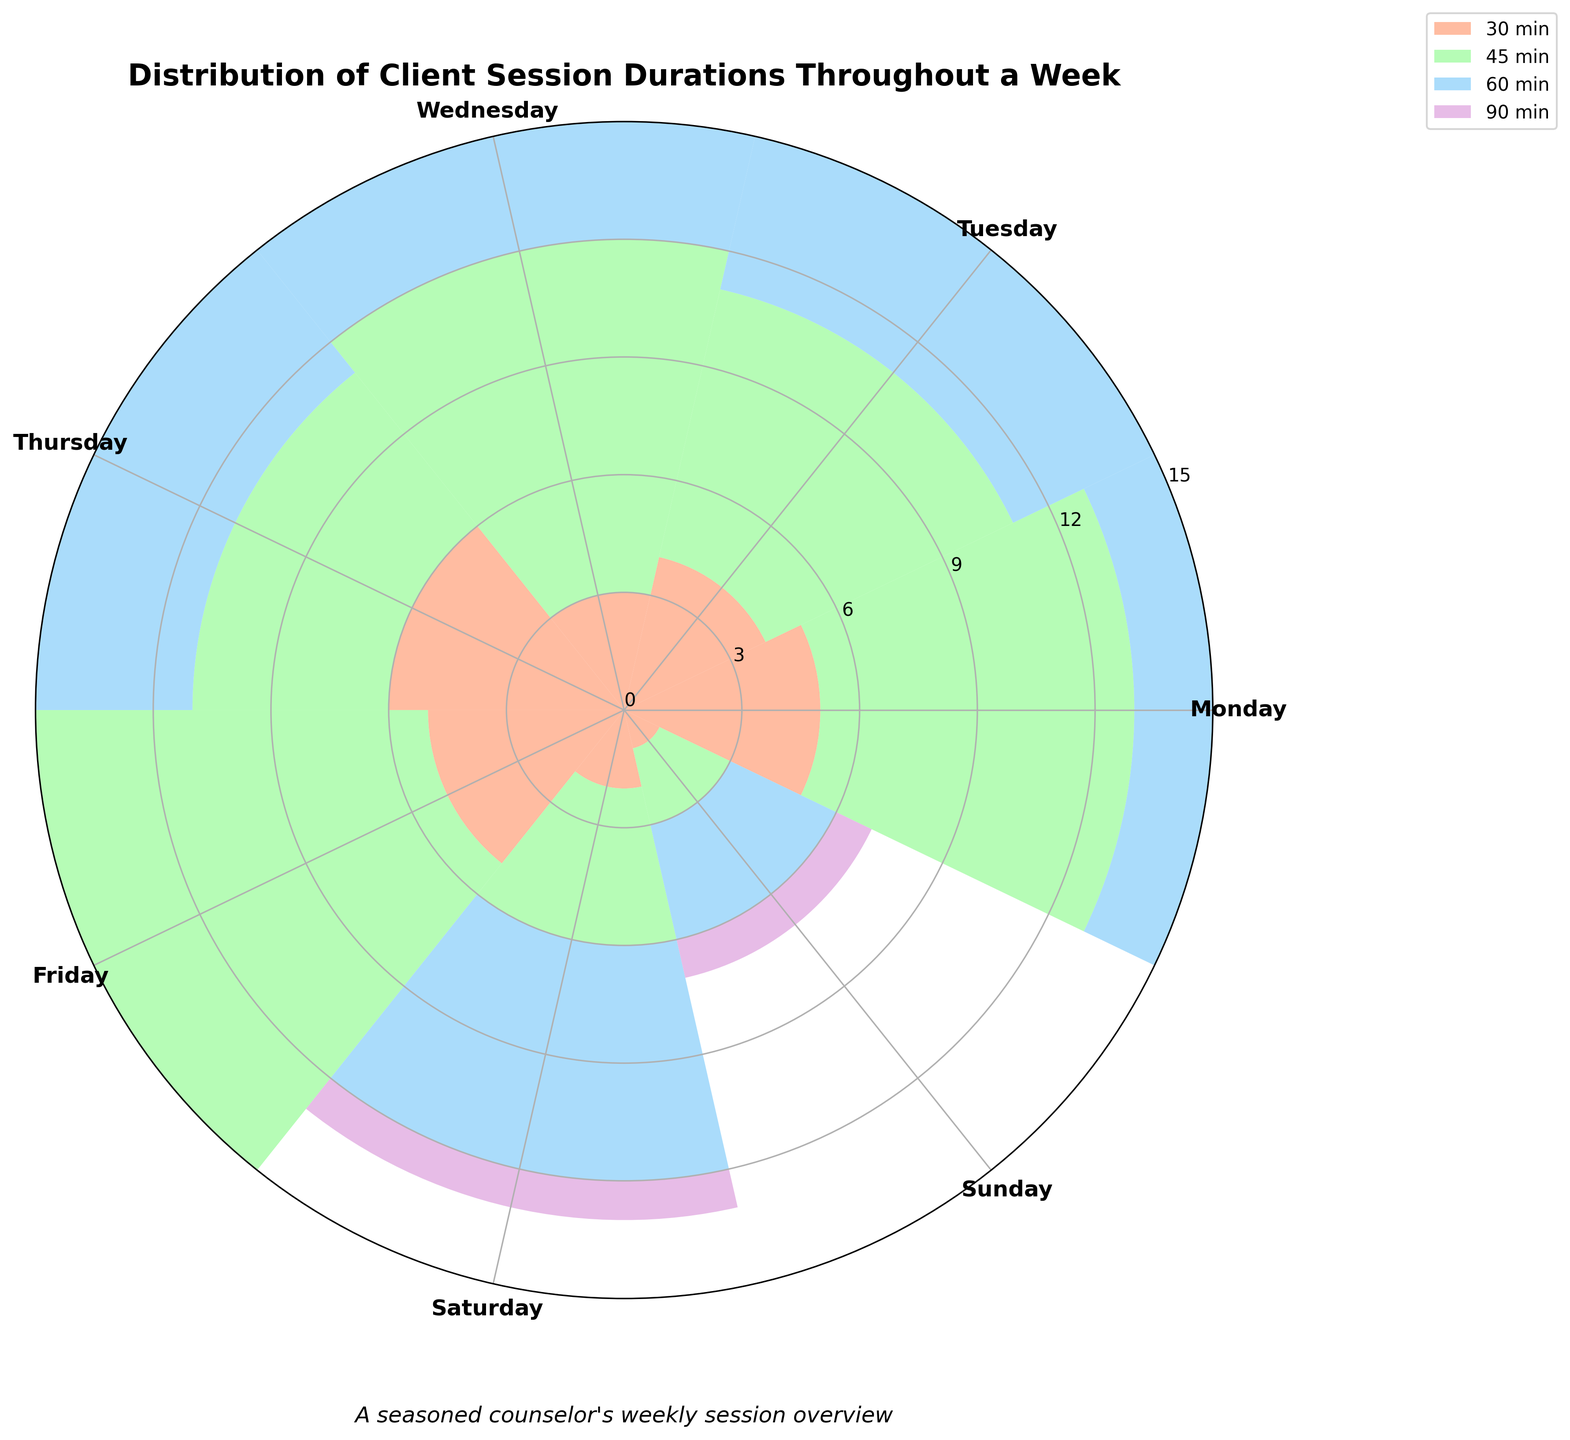Which day has the highest number of 60-minute sessions? Look at the bar heights for 60-minute sessions on each day. Wednesday has the tallest bar for 60-minute sessions.
Answer: Wednesday Which day records the fewest sessions overall? Sum the counts of all session durations for each day. Sunday has the smallest total session count.
Answer: Sunday How many 30-minute sessions are recorded from Monday to Friday? Add the counts of 30-minute sessions from Monday to Friday: 5 (Monday) + 4 (Tuesday) + 3 (Wednesday) + 6 (Thursday) + 5 (Friday) = 23.
Answer: 23 Which duration is the least frequent on Monday? Compare the bar heights for different durations on Monday. The 90-minute session has the smallest count.
Answer: 90 minutes On which day is the difference between the number of 60-minute and 45-minute sessions the greatest? Calculate the difference between 60-minute and 45-minute sessions for each day. The maximum difference is on Wednesday: 12 - 9 = 3.
Answer: Wednesday Which day shows an equal number of 30-minute and 45-minute sessions? Compare the counts of 30-minute and 45-minute sessions for all days. None of the days have equal 30-minute and 45-minute session counts.
Answer: None What's the most common session duration on Thursday? Look at the bar heights for Thursday and identify the duration with the tallest bar. 60-minute sessions are most common on Thursday.
Answer: 60 minutes Which day has the largest number of 45-minute sessions? Check the heights of the bars for 45-minute sessions across all days. Friday has the highest count of 45-minute sessions.
Answer: Friday How many 90-minute sessions are there in total across the week? Sum the counts of 90-minute sessions for each day: 3 (Monday) + 2 (Tuesday) + 4 (Wednesday) + 3 (Thursday) + 3 (Friday) + 1 (Saturday) + 1 (Sunday) = 17.
Answer: 17 On which day is the total number of sessions equal to 15? Sum the session counts for each day and identify the day when the sum is 15. Wednesday has a total of 15 sessions.
Answer: Wednesday 